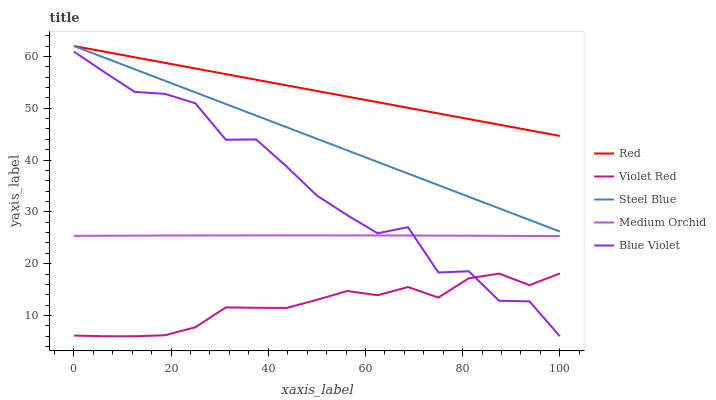Does Violet Red have the minimum area under the curve?
Answer yes or no. Yes. Does Red have the maximum area under the curve?
Answer yes or no. Yes. Does Medium Orchid have the minimum area under the curve?
Answer yes or no. No. Does Medium Orchid have the maximum area under the curve?
Answer yes or no. No. Is Red the smoothest?
Answer yes or no. Yes. Is Blue Violet the roughest?
Answer yes or no. Yes. Is Violet Red the smoothest?
Answer yes or no. No. Is Violet Red the roughest?
Answer yes or no. No. Does Blue Violet have the lowest value?
Answer yes or no. Yes. Does Medium Orchid have the lowest value?
Answer yes or no. No. Does Red have the highest value?
Answer yes or no. Yes. Does Medium Orchid have the highest value?
Answer yes or no. No. Is Blue Violet less than Steel Blue?
Answer yes or no. Yes. Is Steel Blue greater than Blue Violet?
Answer yes or no. Yes. Does Blue Violet intersect Violet Red?
Answer yes or no. Yes. Is Blue Violet less than Violet Red?
Answer yes or no. No. Is Blue Violet greater than Violet Red?
Answer yes or no. No. Does Blue Violet intersect Steel Blue?
Answer yes or no. No. 